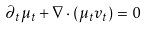<formula> <loc_0><loc_0><loc_500><loc_500>\partial _ { t } \mu _ { t } + \nabla \cdot ( \mu _ { t } v _ { t } ) = 0</formula> 